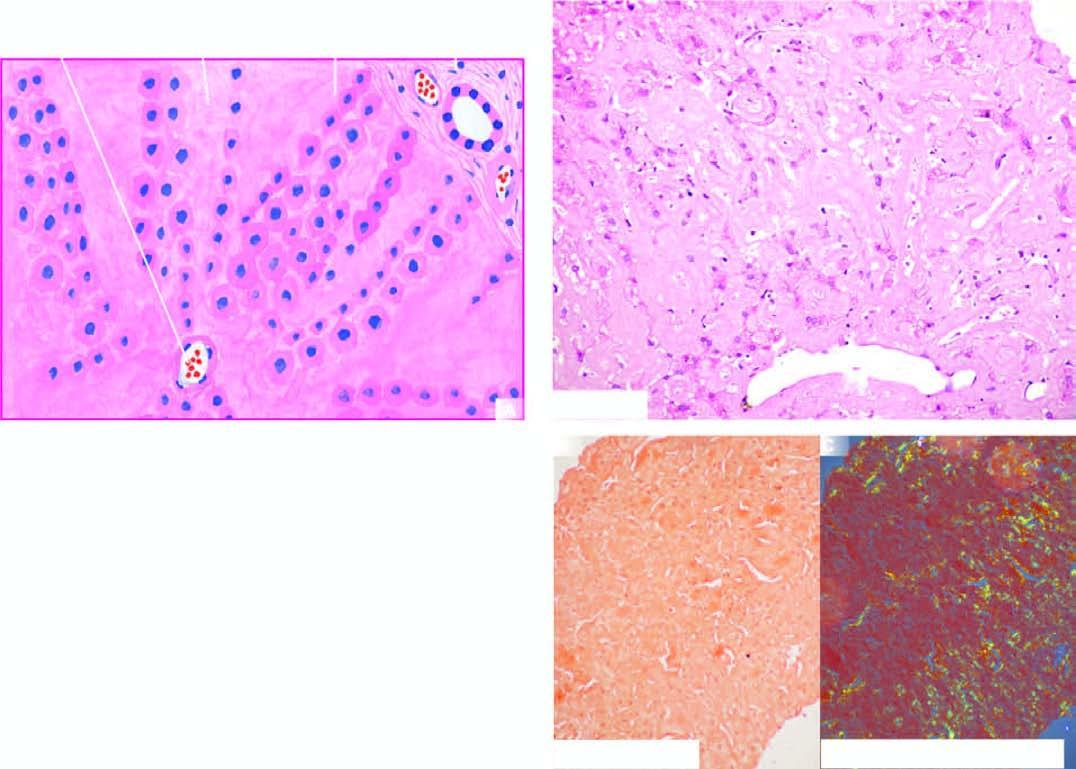where the deposition is extensive causing compression and pressure atrophy of hepatocytes?
Answer the question using a single word or phrase. In the space of disse 